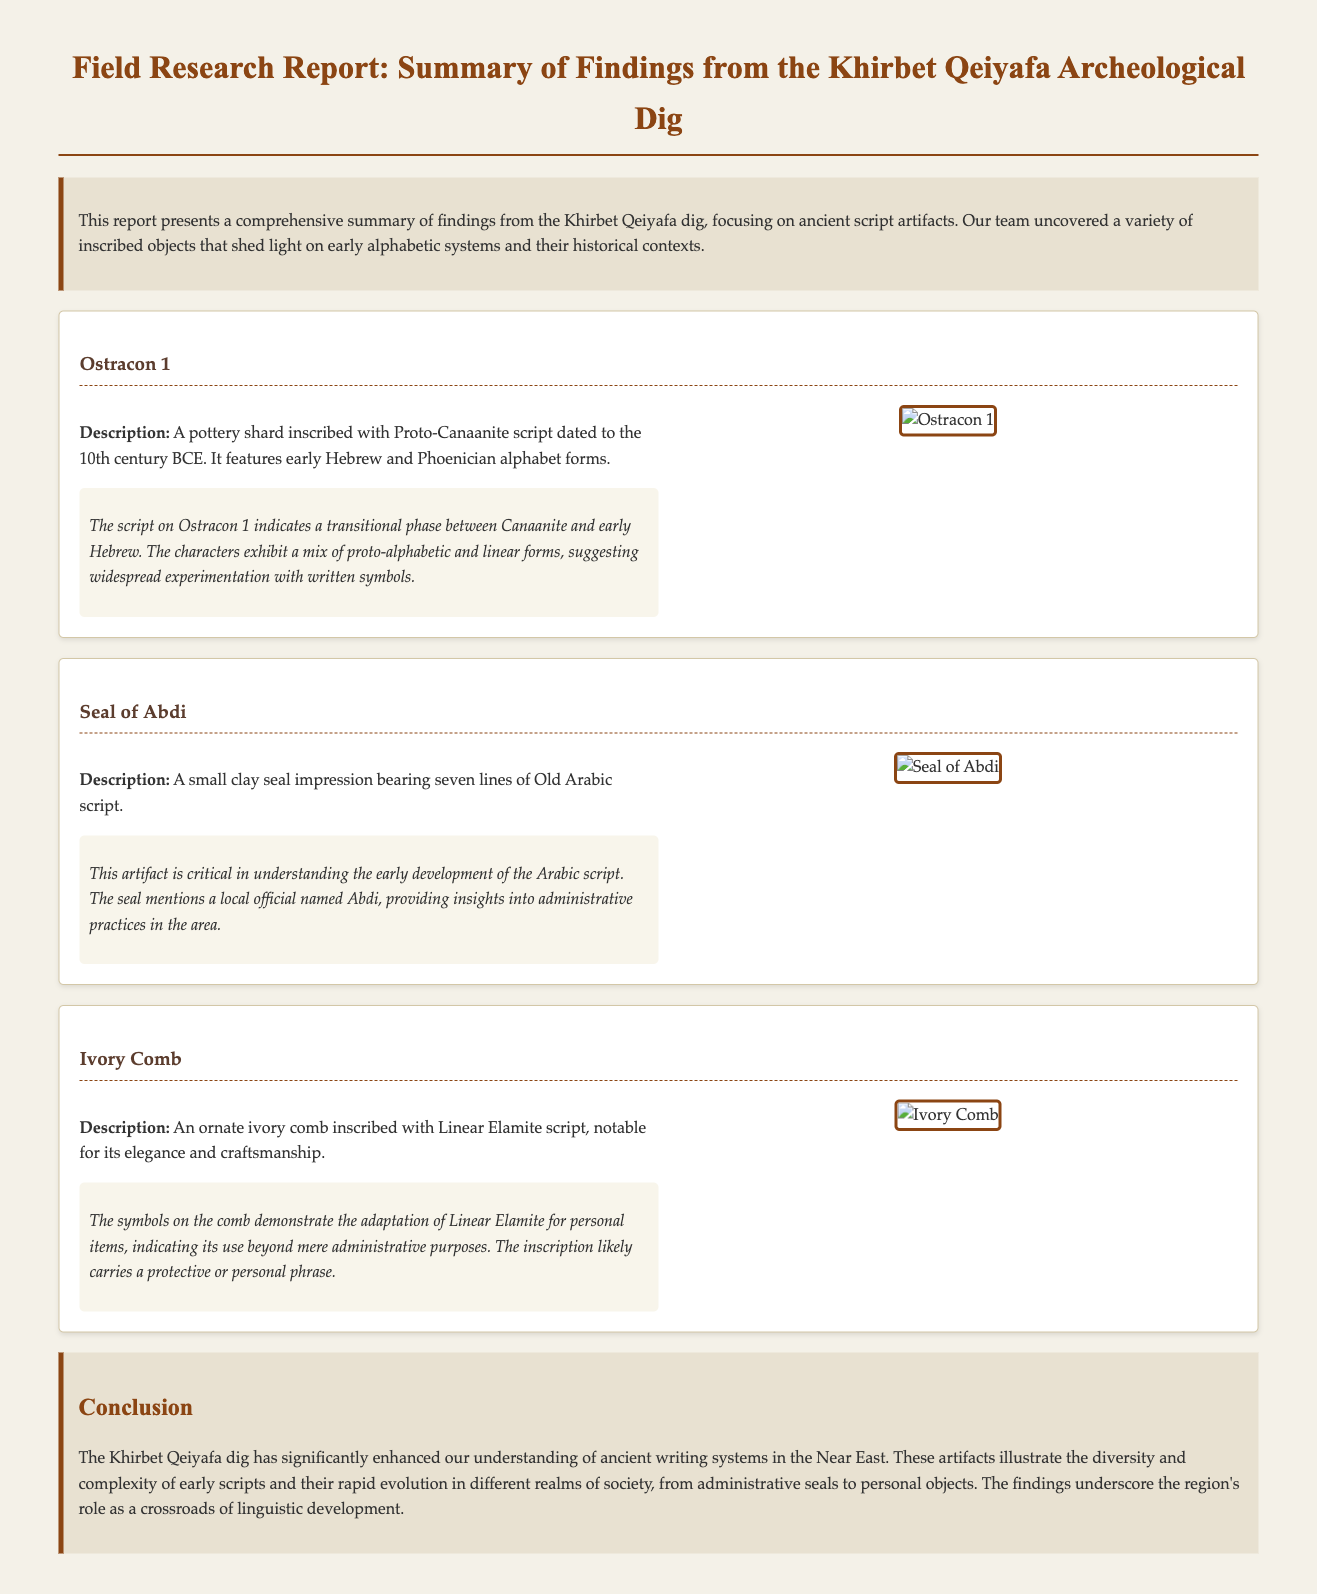What is the title of the report? The title of the report is presented at the beginning of the document, which highlights the focus of the findings.
Answer: Field Research Report: Summary of Findings from the Khirbet Qeiyafa Archeological Dig What is the first artifact mentioned? The first artifact listed in the document provides both a name and a description of the item found during the dig.
Answer: Ostracon 1 Which script is found on the Seal of Abdi? The seal description includes specific information about the type of writing, enhancing understanding of early scripts.
Answer: Old Arabic script What century does Ostracon 1 date to? The date mentioned in the description of Ostracon 1 provides a temporal context for the script inscribed.
Answer: 10th century BCE What is the historical significance of the ivory comb? The interpretive notes detail the function and cultural relevance of the symbols inscribed on the comb, indicating its broader implications.
Answer: Personal items How many lines of script are on the Seal of Abdi? The description specifies the number of inscribed lines, highlighting the level of detail found on the artifact.
Answer: Seven lines What material is the ivory comb made from? The artifact description notes the composition of the comb which is essential to its identification.
Answer: Ivory What region is emphasized in the conclusion as significant for linguistic development? The conclusion summarizes the overall findings and mentions the area that played a crucial role in script evolution.
Answer: Near East 